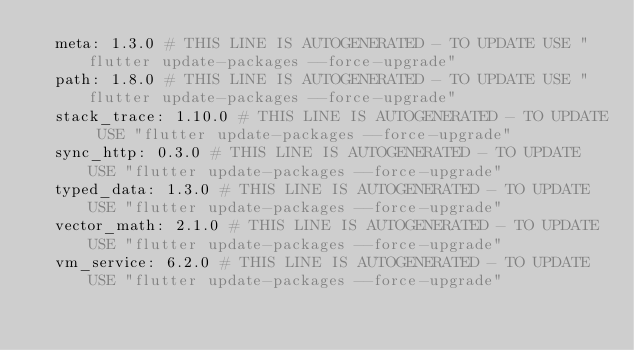<code> <loc_0><loc_0><loc_500><loc_500><_YAML_>  meta: 1.3.0 # THIS LINE IS AUTOGENERATED - TO UPDATE USE "flutter update-packages --force-upgrade"
  path: 1.8.0 # THIS LINE IS AUTOGENERATED - TO UPDATE USE "flutter update-packages --force-upgrade"
  stack_trace: 1.10.0 # THIS LINE IS AUTOGENERATED - TO UPDATE USE "flutter update-packages --force-upgrade"
  sync_http: 0.3.0 # THIS LINE IS AUTOGENERATED - TO UPDATE USE "flutter update-packages --force-upgrade"
  typed_data: 1.3.0 # THIS LINE IS AUTOGENERATED - TO UPDATE USE "flutter update-packages --force-upgrade"
  vector_math: 2.1.0 # THIS LINE IS AUTOGENERATED - TO UPDATE USE "flutter update-packages --force-upgrade"
  vm_service: 6.2.0 # THIS LINE IS AUTOGENERATED - TO UPDATE USE "flutter update-packages --force-upgrade"</code> 